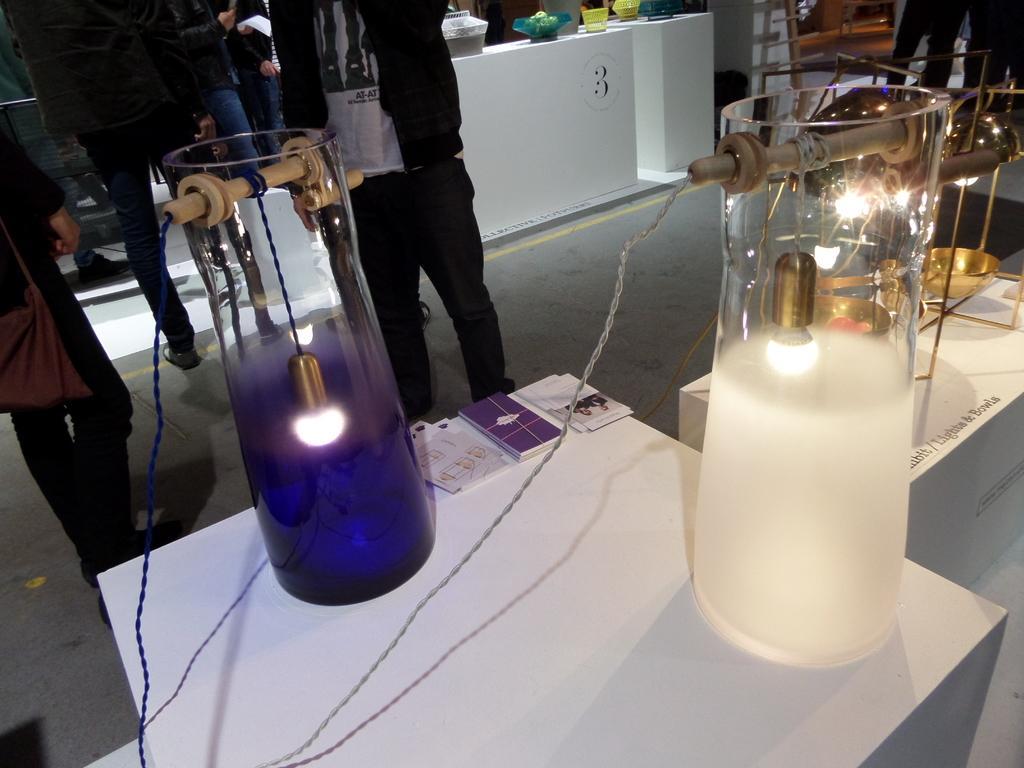Could you give a brief overview of what you see in this image? Here we can see lights, jars, wires, tables, books, and objects. There are few persons standing on the floor. 